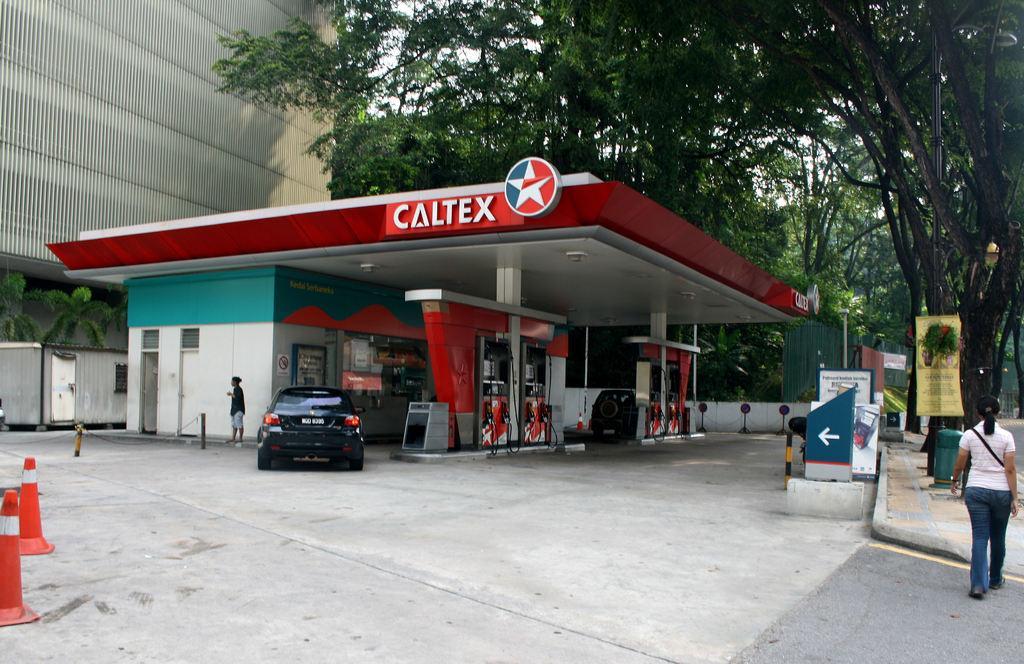Could you give a brief overview of what you see in this image? In this image, this looks like a filling station. I can see two cars Here is the woman walking. I think this is a dustbin. This is a directional board. I can see another person standing. This looks like a building. I can see the trees with branches and leaves. This is the pathway. 